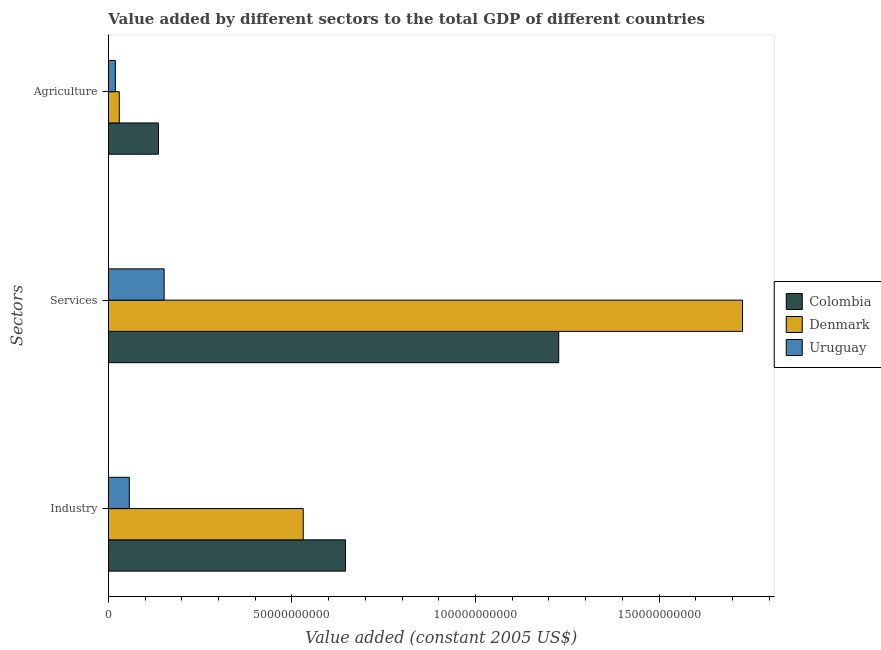How many groups of bars are there?
Ensure brevity in your answer.  3. Are the number of bars per tick equal to the number of legend labels?
Your answer should be very brief. Yes. Are the number of bars on each tick of the Y-axis equal?
Offer a very short reply. Yes. What is the label of the 3rd group of bars from the top?
Offer a very short reply. Industry. What is the value added by agricultural sector in Uruguay?
Offer a terse response. 1.88e+09. Across all countries, what is the maximum value added by services?
Offer a very short reply. 1.73e+11. Across all countries, what is the minimum value added by services?
Offer a terse response. 1.52e+1. In which country was the value added by industrial sector minimum?
Make the answer very short. Uruguay. What is the total value added by agricultural sector in the graph?
Provide a short and direct response. 1.85e+1. What is the difference between the value added by services in Colombia and that in Denmark?
Offer a very short reply. -5.01e+1. What is the difference between the value added by industrial sector in Denmark and the value added by services in Uruguay?
Offer a very short reply. 3.79e+1. What is the average value added by agricultural sector per country?
Ensure brevity in your answer.  6.16e+09. What is the difference between the value added by industrial sector and value added by services in Colombia?
Your answer should be compact. -5.81e+1. What is the ratio of the value added by industrial sector in Denmark to that in Uruguay?
Offer a very short reply. 9.33. What is the difference between the highest and the second highest value added by agricultural sector?
Offer a very short reply. 1.07e+1. What is the difference between the highest and the lowest value added by services?
Your answer should be very brief. 1.58e+11. What does the 2nd bar from the top in Industry represents?
Provide a short and direct response. Denmark. What does the 3rd bar from the bottom in Services represents?
Ensure brevity in your answer.  Uruguay. Are all the bars in the graph horizontal?
Provide a short and direct response. Yes. How many countries are there in the graph?
Your answer should be very brief. 3. Does the graph contain any zero values?
Your answer should be compact. No. Where does the legend appear in the graph?
Provide a succinct answer. Center right. What is the title of the graph?
Ensure brevity in your answer.  Value added by different sectors to the total GDP of different countries. What is the label or title of the X-axis?
Ensure brevity in your answer.  Value added (constant 2005 US$). What is the label or title of the Y-axis?
Ensure brevity in your answer.  Sectors. What is the Value added (constant 2005 US$) of Colombia in Industry?
Make the answer very short. 6.46e+1. What is the Value added (constant 2005 US$) in Denmark in Industry?
Your response must be concise. 5.31e+1. What is the Value added (constant 2005 US$) in Uruguay in Industry?
Make the answer very short. 5.69e+09. What is the Value added (constant 2005 US$) in Colombia in Services?
Give a very brief answer. 1.23e+11. What is the Value added (constant 2005 US$) of Denmark in Services?
Ensure brevity in your answer.  1.73e+11. What is the Value added (constant 2005 US$) of Uruguay in Services?
Keep it short and to the point. 1.52e+1. What is the Value added (constant 2005 US$) of Colombia in Agriculture?
Offer a terse response. 1.36e+1. What is the Value added (constant 2005 US$) of Denmark in Agriculture?
Provide a succinct answer. 2.96e+09. What is the Value added (constant 2005 US$) of Uruguay in Agriculture?
Offer a terse response. 1.88e+09. Across all Sectors, what is the maximum Value added (constant 2005 US$) of Colombia?
Your answer should be compact. 1.23e+11. Across all Sectors, what is the maximum Value added (constant 2005 US$) in Denmark?
Give a very brief answer. 1.73e+11. Across all Sectors, what is the maximum Value added (constant 2005 US$) in Uruguay?
Offer a terse response. 1.52e+1. Across all Sectors, what is the minimum Value added (constant 2005 US$) in Colombia?
Ensure brevity in your answer.  1.36e+1. Across all Sectors, what is the minimum Value added (constant 2005 US$) of Denmark?
Give a very brief answer. 2.96e+09. Across all Sectors, what is the minimum Value added (constant 2005 US$) in Uruguay?
Offer a very short reply. 1.88e+09. What is the total Value added (constant 2005 US$) of Colombia in the graph?
Ensure brevity in your answer.  2.01e+11. What is the total Value added (constant 2005 US$) in Denmark in the graph?
Make the answer very short. 2.29e+11. What is the total Value added (constant 2005 US$) of Uruguay in the graph?
Make the answer very short. 2.27e+1. What is the difference between the Value added (constant 2005 US$) in Colombia in Industry and that in Services?
Make the answer very short. -5.81e+1. What is the difference between the Value added (constant 2005 US$) in Denmark in Industry and that in Services?
Offer a terse response. -1.20e+11. What is the difference between the Value added (constant 2005 US$) of Uruguay in Industry and that in Services?
Keep it short and to the point. -9.49e+09. What is the difference between the Value added (constant 2005 US$) of Colombia in Industry and that in Agriculture?
Ensure brevity in your answer.  5.10e+1. What is the difference between the Value added (constant 2005 US$) of Denmark in Industry and that in Agriculture?
Ensure brevity in your answer.  5.01e+1. What is the difference between the Value added (constant 2005 US$) of Uruguay in Industry and that in Agriculture?
Ensure brevity in your answer.  3.80e+09. What is the difference between the Value added (constant 2005 US$) in Colombia in Services and that in Agriculture?
Make the answer very short. 1.09e+11. What is the difference between the Value added (constant 2005 US$) in Denmark in Services and that in Agriculture?
Make the answer very short. 1.70e+11. What is the difference between the Value added (constant 2005 US$) of Uruguay in Services and that in Agriculture?
Offer a very short reply. 1.33e+1. What is the difference between the Value added (constant 2005 US$) in Colombia in Industry and the Value added (constant 2005 US$) in Denmark in Services?
Offer a terse response. -1.08e+11. What is the difference between the Value added (constant 2005 US$) of Colombia in Industry and the Value added (constant 2005 US$) of Uruguay in Services?
Provide a succinct answer. 4.94e+1. What is the difference between the Value added (constant 2005 US$) in Denmark in Industry and the Value added (constant 2005 US$) in Uruguay in Services?
Provide a short and direct response. 3.79e+1. What is the difference between the Value added (constant 2005 US$) of Colombia in Industry and the Value added (constant 2005 US$) of Denmark in Agriculture?
Provide a succinct answer. 6.16e+1. What is the difference between the Value added (constant 2005 US$) in Colombia in Industry and the Value added (constant 2005 US$) in Uruguay in Agriculture?
Provide a short and direct response. 6.27e+1. What is the difference between the Value added (constant 2005 US$) in Denmark in Industry and the Value added (constant 2005 US$) in Uruguay in Agriculture?
Your answer should be very brief. 5.12e+1. What is the difference between the Value added (constant 2005 US$) of Colombia in Services and the Value added (constant 2005 US$) of Denmark in Agriculture?
Provide a short and direct response. 1.20e+11. What is the difference between the Value added (constant 2005 US$) in Colombia in Services and the Value added (constant 2005 US$) in Uruguay in Agriculture?
Provide a succinct answer. 1.21e+11. What is the difference between the Value added (constant 2005 US$) of Denmark in Services and the Value added (constant 2005 US$) of Uruguay in Agriculture?
Your response must be concise. 1.71e+11. What is the average Value added (constant 2005 US$) of Colombia per Sectors?
Your answer should be very brief. 6.70e+1. What is the average Value added (constant 2005 US$) of Denmark per Sectors?
Provide a succinct answer. 7.63e+1. What is the average Value added (constant 2005 US$) of Uruguay per Sectors?
Keep it short and to the point. 7.58e+09. What is the difference between the Value added (constant 2005 US$) of Colombia and Value added (constant 2005 US$) of Denmark in Industry?
Give a very brief answer. 1.15e+1. What is the difference between the Value added (constant 2005 US$) in Colombia and Value added (constant 2005 US$) in Uruguay in Industry?
Offer a very short reply. 5.89e+1. What is the difference between the Value added (constant 2005 US$) of Denmark and Value added (constant 2005 US$) of Uruguay in Industry?
Provide a short and direct response. 4.74e+1. What is the difference between the Value added (constant 2005 US$) of Colombia and Value added (constant 2005 US$) of Denmark in Services?
Provide a short and direct response. -5.01e+1. What is the difference between the Value added (constant 2005 US$) of Colombia and Value added (constant 2005 US$) of Uruguay in Services?
Your answer should be compact. 1.07e+11. What is the difference between the Value added (constant 2005 US$) in Denmark and Value added (constant 2005 US$) in Uruguay in Services?
Keep it short and to the point. 1.58e+11. What is the difference between the Value added (constant 2005 US$) of Colombia and Value added (constant 2005 US$) of Denmark in Agriculture?
Keep it short and to the point. 1.07e+1. What is the difference between the Value added (constant 2005 US$) in Colombia and Value added (constant 2005 US$) in Uruguay in Agriculture?
Give a very brief answer. 1.17e+1. What is the difference between the Value added (constant 2005 US$) of Denmark and Value added (constant 2005 US$) of Uruguay in Agriculture?
Provide a succinct answer. 1.07e+09. What is the ratio of the Value added (constant 2005 US$) in Colombia in Industry to that in Services?
Give a very brief answer. 0.53. What is the ratio of the Value added (constant 2005 US$) in Denmark in Industry to that in Services?
Provide a succinct answer. 0.31. What is the ratio of the Value added (constant 2005 US$) in Uruguay in Industry to that in Services?
Keep it short and to the point. 0.37. What is the ratio of the Value added (constant 2005 US$) in Colombia in Industry to that in Agriculture?
Your answer should be very brief. 4.74. What is the ratio of the Value added (constant 2005 US$) in Denmark in Industry to that in Agriculture?
Keep it short and to the point. 17.95. What is the ratio of the Value added (constant 2005 US$) of Uruguay in Industry to that in Agriculture?
Give a very brief answer. 3.02. What is the ratio of the Value added (constant 2005 US$) in Colombia in Services to that in Agriculture?
Give a very brief answer. 9. What is the ratio of the Value added (constant 2005 US$) in Denmark in Services to that in Agriculture?
Give a very brief answer. 58.43. What is the ratio of the Value added (constant 2005 US$) in Uruguay in Services to that in Agriculture?
Your response must be concise. 8.05. What is the difference between the highest and the second highest Value added (constant 2005 US$) of Colombia?
Provide a short and direct response. 5.81e+1. What is the difference between the highest and the second highest Value added (constant 2005 US$) of Denmark?
Your response must be concise. 1.20e+11. What is the difference between the highest and the second highest Value added (constant 2005 US$) of Uruguay?
Provide a succinct answer. 9.49e+09. What is the difference between the highest and the lowest Value added (constant 2005 US$) of Colombia?
Provide a short and direct response. 1.09e+11. What is the difference between the highest and the lowest Value added (constant 2005 US$) in Denmark?
Offer a terse response. 1.70e+11. What is the difference between the highest and the lowest Value added (constant 2005 US$) of Uruguay?
Your answer should be compact. 1.33e+1. 